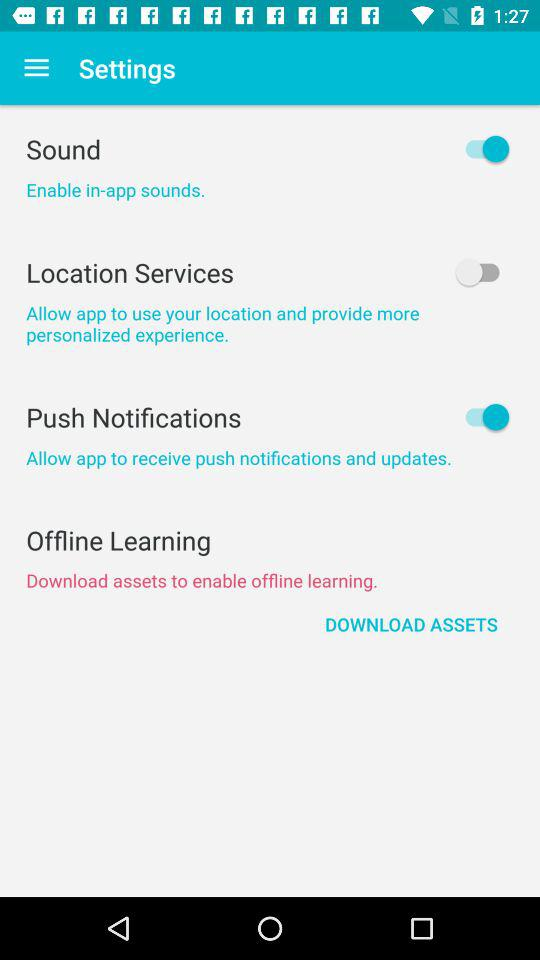What's the status of "Push Notifications"? The status of "Push Notifications" is "on". 